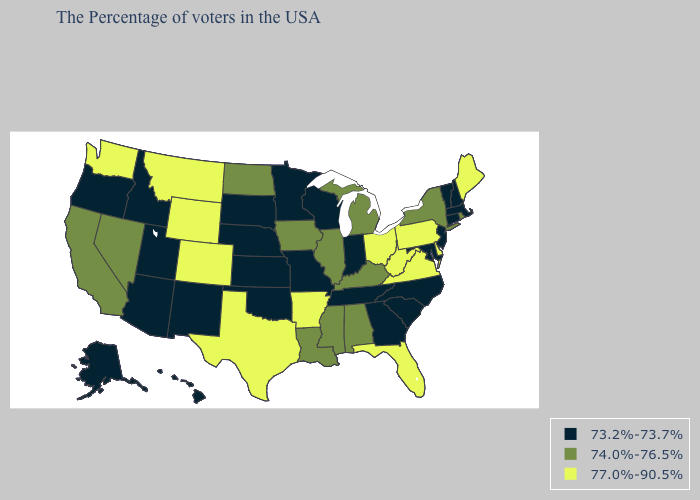What is the value of Michigan?
Quick response, please. 74.0%-76.5%. Name the states that have a value in the range 77.0%-90.5%?
Short answer required. Maine, Delaware, Pennsylvania, Virginia, West Virginia, Ohio, Florida, Arkansas, Texas, Wyoming, Colorado, Montana, Washington. What is the value of Alabama?
Keep it brief. 74.0%-76.5%. What is the value of Hawaii?
Write a very short answer. 73.2%-73.7%. Does Oklahoma have the lowest value in the USA?
Concise answer only. Yes. Does Tennessee have a higher value than Vermont?
Give a very brief answer. No. Does the first symbol in the legend represent the smallest category?
Quick response, please. Yes. Does Georgia have a higher value than Arkansas?
Be succinct. No. Which states have the lowest value in the South?
Keep it brief. Maryland, North Carolina, South Carolina, Georgia, Tennessee, Oklahoma. Among the states that border Wyoming , does Colorado have the highest value?
Keep it brief. Yes. What is the lowest value in the Northeast?
Keep it brief. 73.2%-73.7%. Is the legend a continuous bar?
Give a very brief answer. No. What is the value of Kentucky?
Short answer required. 74.0%-76.5%. Name the states that have a value in the range 77.0%-90.5%?
Answer briefly. Maine, Delaware, Pennsylvania, Virginia, West Virginia, Ohio, Florida, Arkansas, Texas, Wyoming, Colorado, Montana, Washington. How many symbols are there in the legend?
Concise answer only. 3. 